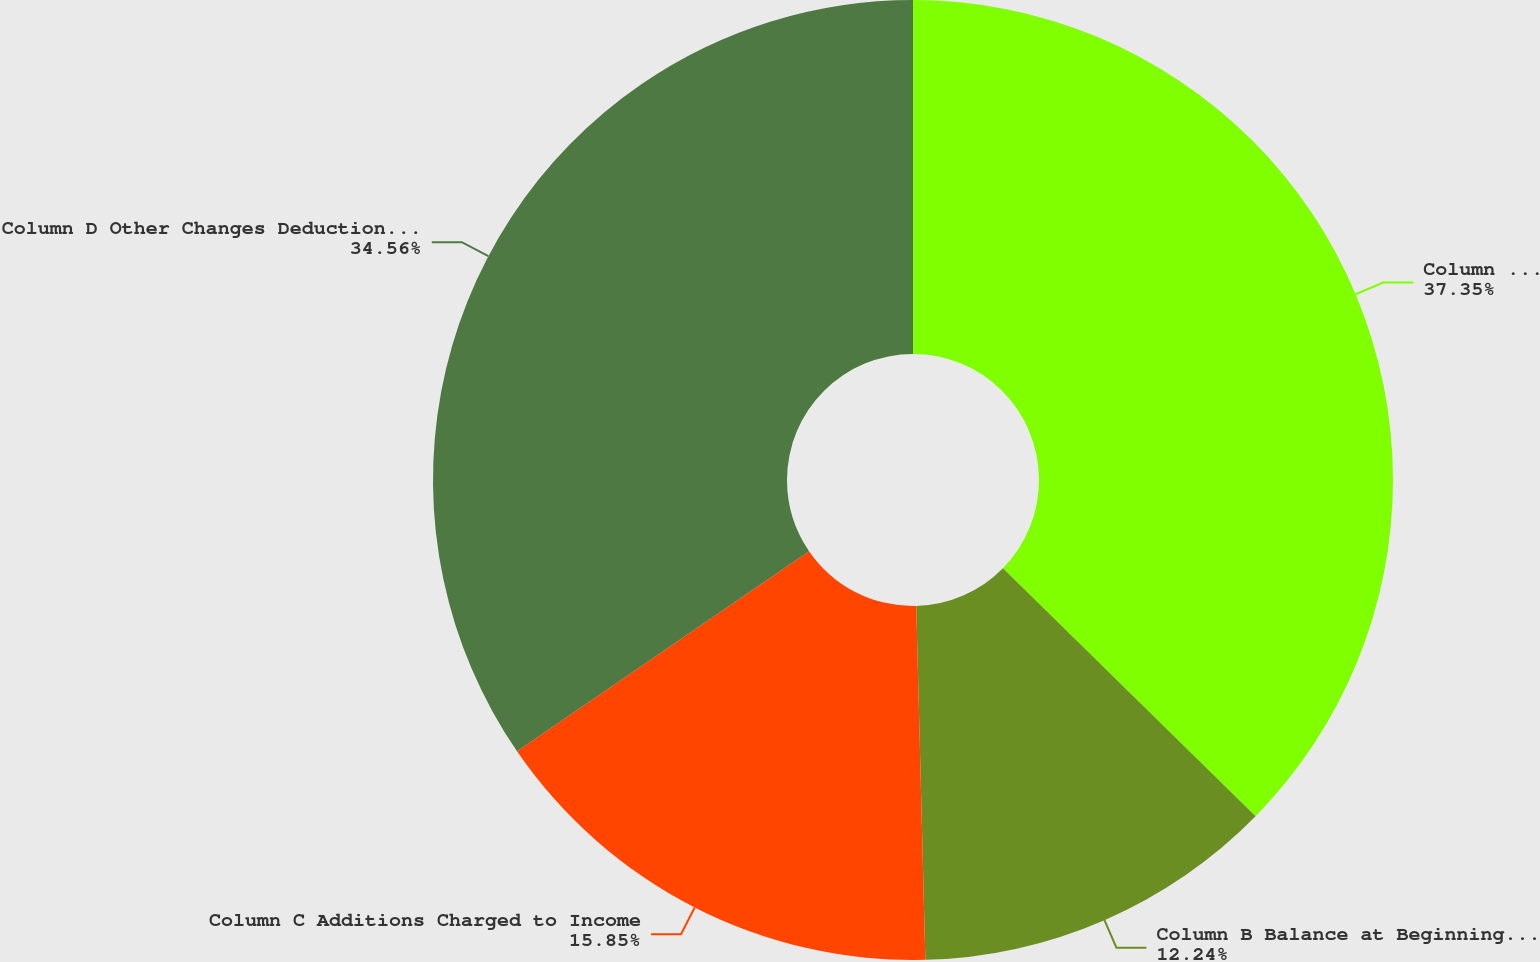<chart> <loc_0><loc_0><loc_500><loc_500><pie_chart><fcel>Column E Balance at End of Period<fcel>Column B Balance at Beginning  of Period<fcel>Column C Additions Charged to Income<fcel>Column D Other Changes Deductions (1)<nl><fcel>37.35%<fcel>12.24%<fcel>15.85%<fcel>34.56%<nl></chart> 